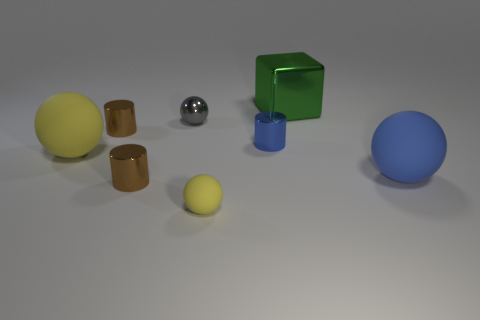Subtract all brown balls. How many brown cylinders are left? 2 Subtract all tiny brown metal cylinders. How many cylinders are left? 1 Subtract all blue spheres. How many spheres are left? 3 Add 2 tiny blue cylinders. How many objects exist? 10 Subtract all red balls. Subtract all cyan cylinders. How many balls are left? 4 Subtract all cubes. How many objects are left? 7 Add 5 cylinders. How many cylinders exist? 8 Subtract 0 green balls. How many objects are left? 8 Subtract all balls. Subtract all big yellow matte objects. How many objects are left? 3 Add 1 big blue spheres. How many big blue spheres are left? 2 